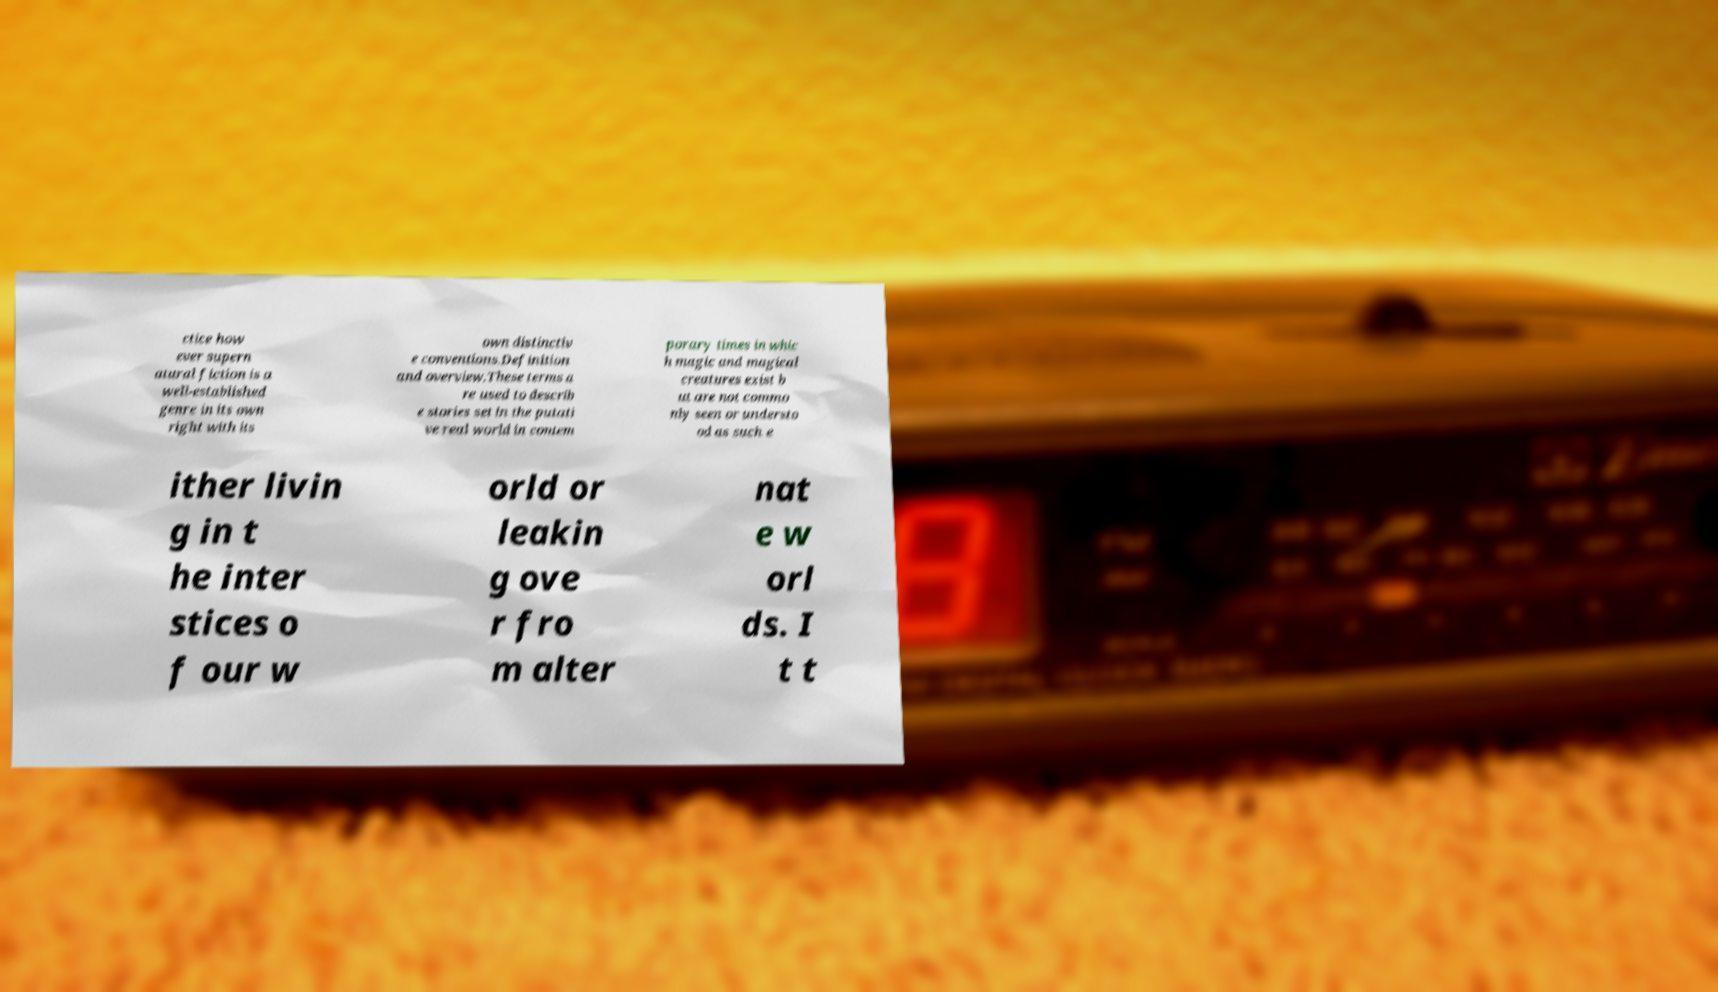For documentation purposes, I need the text within this image transcribed. Could you provide that? ctice how ever supern atural fiction is a well-established genre in its own right with its own distinctiv e conventions.Definition and overview.These terms a re used to describ e stories set in the putati ve real world in contem porary times in whic h magic and magical creatures exist b ut are not commo nly seen or understo od as such e ither livin g in t he inter stices o f our w orld or leakin g ove r fro m alter nat e w orl ds. I t t 